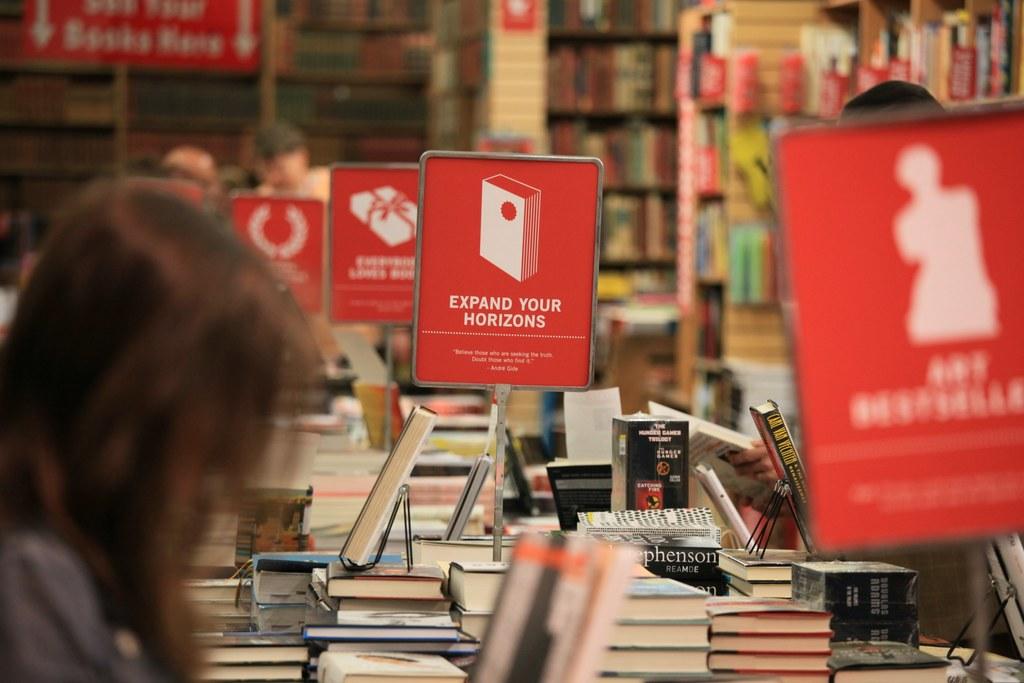What do the signs ask you to do?
Give a very brief answer. Expand your horizons. What is the name on the side of the black book, it starts with a r?
Ensure brevity in your answer.  Reamde. 